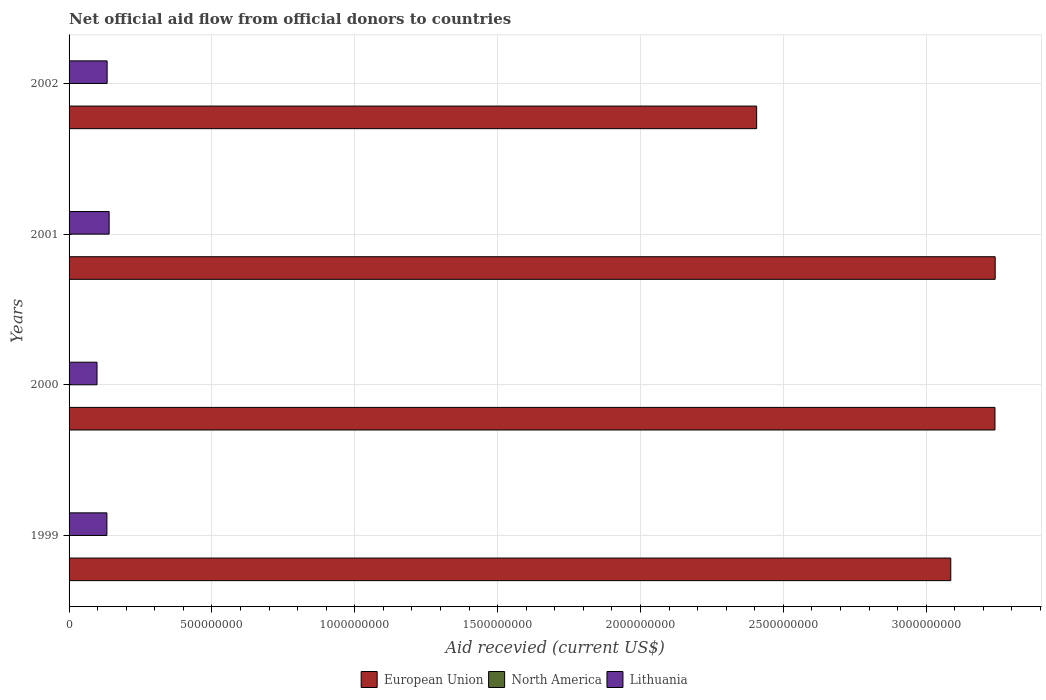How many different coloured bars are there?
Provide a short and direct response. 3. Are the number of bars on each tick of the Y-axis equal?
Provide a succinct answer. Yes. How many bars are there on the 4th tick from the bottom?
Offer a very short reply. 3. What is the total aid received in European Union in 2001?
Offer a very short reply. 3.24e+09. Across all years, what is the maximum total aid received in European Union?
Keep it short and to the point. 3.24e+09. Across all years, what is the minimum total aid received in Lithuania?
Offer a terse response. 9.78e+07. What is the total total aid received in Lithuania in the graph?
Offer a very short reply. 5.04e+08. What is the difference between the total aid received in North America in 1999 and the total aid received in European Union in 2002?
Provide a short and direct response. -2.41e+09. What is the average total aid received in North America per year?
Your response must be concise. 4.50e+04. In the year 2002, what is the difference between the total aid received in Lithuania and total aid received in North America?
Give a very brief answer. 1.33e+08. What is the ratio of the total aid received in European Union in 1999 to that in 2000?
Offer a very short reply. 0.95. What is the difference between the highest and the second highest total aid received in Lithuania?
Ensure brevity in your answer.  7.02e+06. What is the difference between the highest and the lowest total aid received in Lithuania?
Make the answer very short. 4.24e+07. Is the sum of the total aid received in European Union in 1999 and 2002 greater than the maximum total aid received in North America across all years?
Your response must be concise. Yes. What does the 1st bar from the top in 2002 represents?
Make the answer very short. Lithuania. How many bars are there?
Offer a very short reply. 12. How many years are there in the graph?
Provide a succinct answer. 4. What is the difference between two consecutive major ticks on the X-axis?
Your answer should be compact. 5.00e+08. Does the graph contain any zero values?
Provide a short and direct response. No. Where does the legend appear in the graph?
Your answer should be very brief. Bottom center. What is the title of the graph?
Give a very brief answer. Net official aid flow from official donors to countries. What is the label or title of the X-axis?
Make the answer very short. Aid recevied (current US$). What is the Aid recevied (current US$) in European Union in 1999?
Your answer should be very brief. 3.09e+09. What is the Aid recevied (current US$) of Lithuania in 1999?
Offer a terse response. 1.32e+08. What is the Aid recevied (current US$) of European Union in 2000?
Your answer should be very brief. 3.24e+09. What is the Aid recevied (current US$) of Lithuania in 2000?
Provide a succinct answer. 9.78e+07. What is the Aid recevied (current US$) of European Union in 2001?
Offer a very short reply. 3.24e+09. What is the Aid recevied (current US$) in North America in 2001?
Provide a succinct answer. 2.00e+04. What is the Aid recevied (current US$) of Lithuania in 2001?
Your response must be concise. 1.40e+08. What is the Aid recevied (current US$) of European Union in 2002?
Give a very brief answer. 2.41e+09. What is the Aid recevied (current US$) in Lithuania in 2002?
Keep it short and to the point. 1.33e+08. Across all years, what is the maximum Aid recevied (current US$) of European Union?
Your answer should be compact. 3.24e+09. Across all years, what is the maximum Aid recevied (current US$) in Lithuania?
Provide a succinct answer. 1.40e+08. Across all years, what is the minimum Aid recevied (current US$) in European Union?
Give a very brief answer. 2.41e+09. Across all years, what is the minimum Aid recevied (current US$) of Lithuania?
Give a very brief answer. 9.78e+07. What is the total Aid recevied (current US$) in European Union in the graph?
Provide a succinct answer. 1.20e+1. What is the total Aid recevied (current US$) in North America in the graph?
Ensure brevity in your answer.  1.80e+05. What is the total Aid recevied (current US$) of Lithuania in the graph?
Provide a short and direct response. 5.04e+08. What is the difference between the Aid recevied (current US$) in European Union in 1999 and that in 2000?
Your response must be concise. -1.55e+08. What is the difference between the Aid recevied (current US$) in Lithuania in 1999 and that in 2000?
Provide a short and direct response. 3.46e+07. What is the difference between the Aid recevied (current US$) of European Union in 1999 and that in 2001?
Offer a terse response. -1.55e+08. What is the difference between the Aid recevied (current US$) in Lithuania in 1999 and that in 2001?
Offer a terse response. -7.83e+06. What is the difference between the Aid recevied (current US$) in European Union in 1999 and that in 2002?
Your answer should be very brief. 6.79e+08. What is the difference between the Aid recevied (current US$) in Lithuania in 1999 and that in 2002?
Make the answer very short. -8.10e+05. What is the difference between the Aid recevied (current US$) of European Union in 2000 and that in 2001?
Provide a short and direct response. -7.70e+05. What is the difference between the Aid recevied (current US$) of North America in 2000 and that in 2001?
Your response must be concise. 4.00e+04. What is the difference between the Aid recevied (current US$) of Lithuania in 2000 and that in 2001?
Provide a succinct answer. -4.24e+07. What is the difference between the Aid recevied (current US$) in European Union in 2000 and that in 2002?
Keep it short and to the point. 8.34e+08. What is the difference between the Aid recevied (current US$) in Lithuania in 2000 and that in 2002?
Offer a very short reply. -3.54e+07. What is the difference between the Aid recevied (current US$) in European Union in 2001 and that in 2002?
Offer a terse response. 8.35e+08. What is the difference between the Aid recevied (current US$) in North America in 2001 and that in 2002?
Offer a terse response. 0. What is the difference between the Aid recevied (current US$) of Lithuania in 2001 and that in 2002?
Your response must be concise. 7.02e+06. What is the difference between the Aid recevied (current US$) of European Union in 1999 and the Aid recevied (current US$) of North America in 2000?
Ensure brevity in your answer.  3.09e+09. What is the difference between the Aid recevied (current US$) in European Union in 1999 and the Aid recevied (current US$) in Lithuania in 2000?
Provide a succinct answer. 2.99e+09. What is the difference between the Aid recevied (current US$) in North America in 1999 and the Aid recevied (current US$) in Lithuania in 2000?
Your response must be concise. -9.77e+07. What is the difference between the Aid recevied (current US$) of European Union in 1999 and the Aid recevied (current US$) of North America in 2001?
Offer a terse response. 3.09e+09. What is the difference between the Aid recevied (current US$) of European Union in 1999 and the Aid recevied (current US$) of Lithuania in 2001?
Make the answer very short. 2.95e+09. What is the difference between the Aid recevied (current US$) of North America in 1999 and the Aid recevied (current US$) of Lithuania in 2001?
Give a very brief answer. -1.40e+08. What is the difference between the Aid recevied (current US$) in European Union in 1999 and the Aid recevied (current US$) in North America in 2002?
Offer a terse response. 3.09e+09. What is the difference between the Aid recevied (current US$) in European Union in 1999 and the Aid recevied (current US$) in Lithuania in 2002?
Offer a terse response. 2.95e+09. What is the difference between the Aid recevied (current US$) of North America in 1999 and the Aid recevied (current US$) of Lithuania in 2002?
Provide a short and direct response. -1.33e+08. What is the difference between the Aid recevied (current US$) of European Union in 2000 and the Aid recevied (current US$) of North America in 2001?
Provide a short and direct response. 3.24e+09. What is the difference between the Aid recevied (current US$) of European Union in 2000 and the Aid recevied (current US$) of Lithuania in 2001?
Provide a short and direct response. 3.10e+09. What is the difference between the Aid recevied (current US$) in North America in 2000 and the Aid recevied (current US$) in Lithuania in 2001?
Your response must be concise. -1.40e+08. What is the difference between the Aid recevied (current US$) in European Union in 2000 and the Aid recevied (current US$) in North America in 2002?
Ensure brevity in your answer.  3.24e+09. What is the difference between the Aid recevied (current US$) in European Union in 2000 and the Aid recevied (current US$) in Lithuania in 2002?
Make the answer very short. 3.11e+09. What is the difference between the Aid recevied (current US$) of North America in 2000 and the Aid recevied (current US$) of Lithuania in 2002?
Provide a short and direct response. -1.33e+08. What is the difference between the Aid recevied (current US$) in European Union in 2001 and the Aid recevied (current US$) in North America in 2002?
Make the answer very short. 3.24e+09. What is the difference between the Aid recevied (current US$) of European Union in 2001 and the Aid recevied (current US$) of Lithuania in 2002?
Provide a succinct answer. 3.11e+09. What is the difference between the Aid recevied (current US$) in North America in 2001 and the Aid recevied (current US$) in Lithuania in 2002?
Your response must be concise. -1.33e+08. What is the average Aid recevied (current US$) of European Union per year?
Offer a very short reply. 2.99e+09. What is the average Aid recevied (current US$) of North America per year?
Offer a terse response. 4.50e+04. What is the average Aid recevied (current US$) in Lithuania per year?
Your response must be concise. 1.26e+08. In the year 1999, what is the difference between the Aid recevied (current US$) in European Union and Aid recevied (current US$) in North America?
Your response must be concise. 3.09e+09. In the year 1999, what is the difference between the Aid recevied (current US$) in European Union and Aid recevied (current US$) in Lithuania?
Offer a very short reply. 2.95e+09. In the year 1999, what is the difference between the Aid recevied (current US$) in North America and Aid recevied (current US$) in Lithuania?
Offer a terse response. -1.32e+08. In the year 2000, what is the difference between the Aid recevied (current US$) of European Union and Aid recevied (current US$) of North America?
Your answer should be compact. 3.24e+09. In the year 2000, what is the difference between the Aid recevied (current US$) of European Union and Aid recevied (current US$) of Lithuania?
Your response must be concise. 3.14e+09. In the year 2000, what is the difference between the Aid recevied (current US$) in North America and Aid recevied (current US$) in Lithuania?
Provide a succinct answer. -9.78e+07. In the year 2001, what is the difference between the Aid recevied (current US$) of European Union and Aid recevied (current US$) of North America?
Give a very brief answer. 3.24e+09. In the year 2001, what is the difference between the Aid recevied (current US$) of European Union and Aid recevied (current US$) of Lithuania?
Keep it short and to the point. 3.10e+09. In the year 2001, what is the difference between the Aid recevied (current US$) of North America and Aid recevied (current US$) of Lithuania?
Your answer should be very brief. -1.40e+08. In the year 2002, what is the difference between the Aid recevied (current US$) in European Union and Aid recevied (current US$) in North America?
Give a very brief answer. 2.41e+09. In the year 2002, what is the difference between the Aid recevied (current US$) of European Union and Aid recevied (current US$) of Lithuania?
Ensure brevity in your answer.  2.27e+09. In the year 2002, what is the difference between the Aid recevied (current US$) in North America and Aid recevied (current US$) in Lithuania?
Your answer should be compact. -1.33e+08. What is the ratio of the Aid recevied (current US$) in European Union in 1999 to that in 2000?
Offer a terse response. 0.95. What is the ratio of the Aid recevied (current US$) of North America in 1999 to that in 2000?
Provide a short and direct response. 1.33. What is the ratio of the Aid recevied (current US$) in Lithuania in 1999 to that in 2000?
Give a very brief answer. 1.35. What is the ratio of the Aid recevied (current US$) in European Union in 1999 to that in 2001?
Provide a succinct answer. 0.95. What is the ratio of the Aid recevied (current US$) in Lithuania in 1999 to that in 2001?
Offer a terse response. 0.94. What is the ratio of the Aid recevied (current US$) in European Union in 1999 to that in 2002?
Keep it short and to the point. 1.28. What is the ratio of the Aid recevied (current US$) of North America in 1999 to that in 2002?
Give a very brief answer. 4. What is the ratio of the Aid recevied (current US$) in Lithuania in 1999 to that in 2002?
Your response must be concise. 0.99. What is the ratio of the Aid recevied (current US$) in European Union in 2000 to that in 2001?
Keep it short and to the point. 1. What is the ratio of the Aid recevied (current US$) of North America in 2000 to that in 2001?
Ensure brevity in your answer.  3. What is the ratio of the Aid recevied (current US$) of Lithuania in 2000 to that in 2001?
Ensure brevity in your answer.  0.7. What is the ratio of the Aid recevied (current US$) of European Union in 2000 to that in 2002?
Your response must be concise. 1.35. What is the ratio of the Aid recevied (current US$) in North America in 2000 to that in 2002?
Provide a short and direct response. 3. What is the ratio of the Aid recevied (current US$) of Lithuania in 2000 to that in 2002?
Your answer should be very brief. 0.73. What is the ratio of the Aid recevied (current US$) of European Union in 2001 to that in 2002?
Ensure brevity in your answer.  1.35. What is the ratio of the Aid recevied (current US$) of North America in 2001 to that in 2002?
Provide a succinct answer. 1. What is the ratio of the Aid recevied (current US$) of Lithuania in 2001 to that in 2002?
Your answer should be very brief. 1.05. What is the difference between the highest and the second highest Aid recevied (current US$) of European Union?
Your response must be concise. 7.70e+05. What is the difference between the highest and the second highest Aid recevied (current US$) in Lithuania?
Keep it short and to the point. 7.02e+06. What is the difference between the highest and the lowest Aid recevied (current US$) of European Union?
Your response must be concise. 8.35e+08. What is the difference between the highest and the lowest Aid recevied (current US$) of Lithuania?
Give a very brief answer. 4.24e+07. 